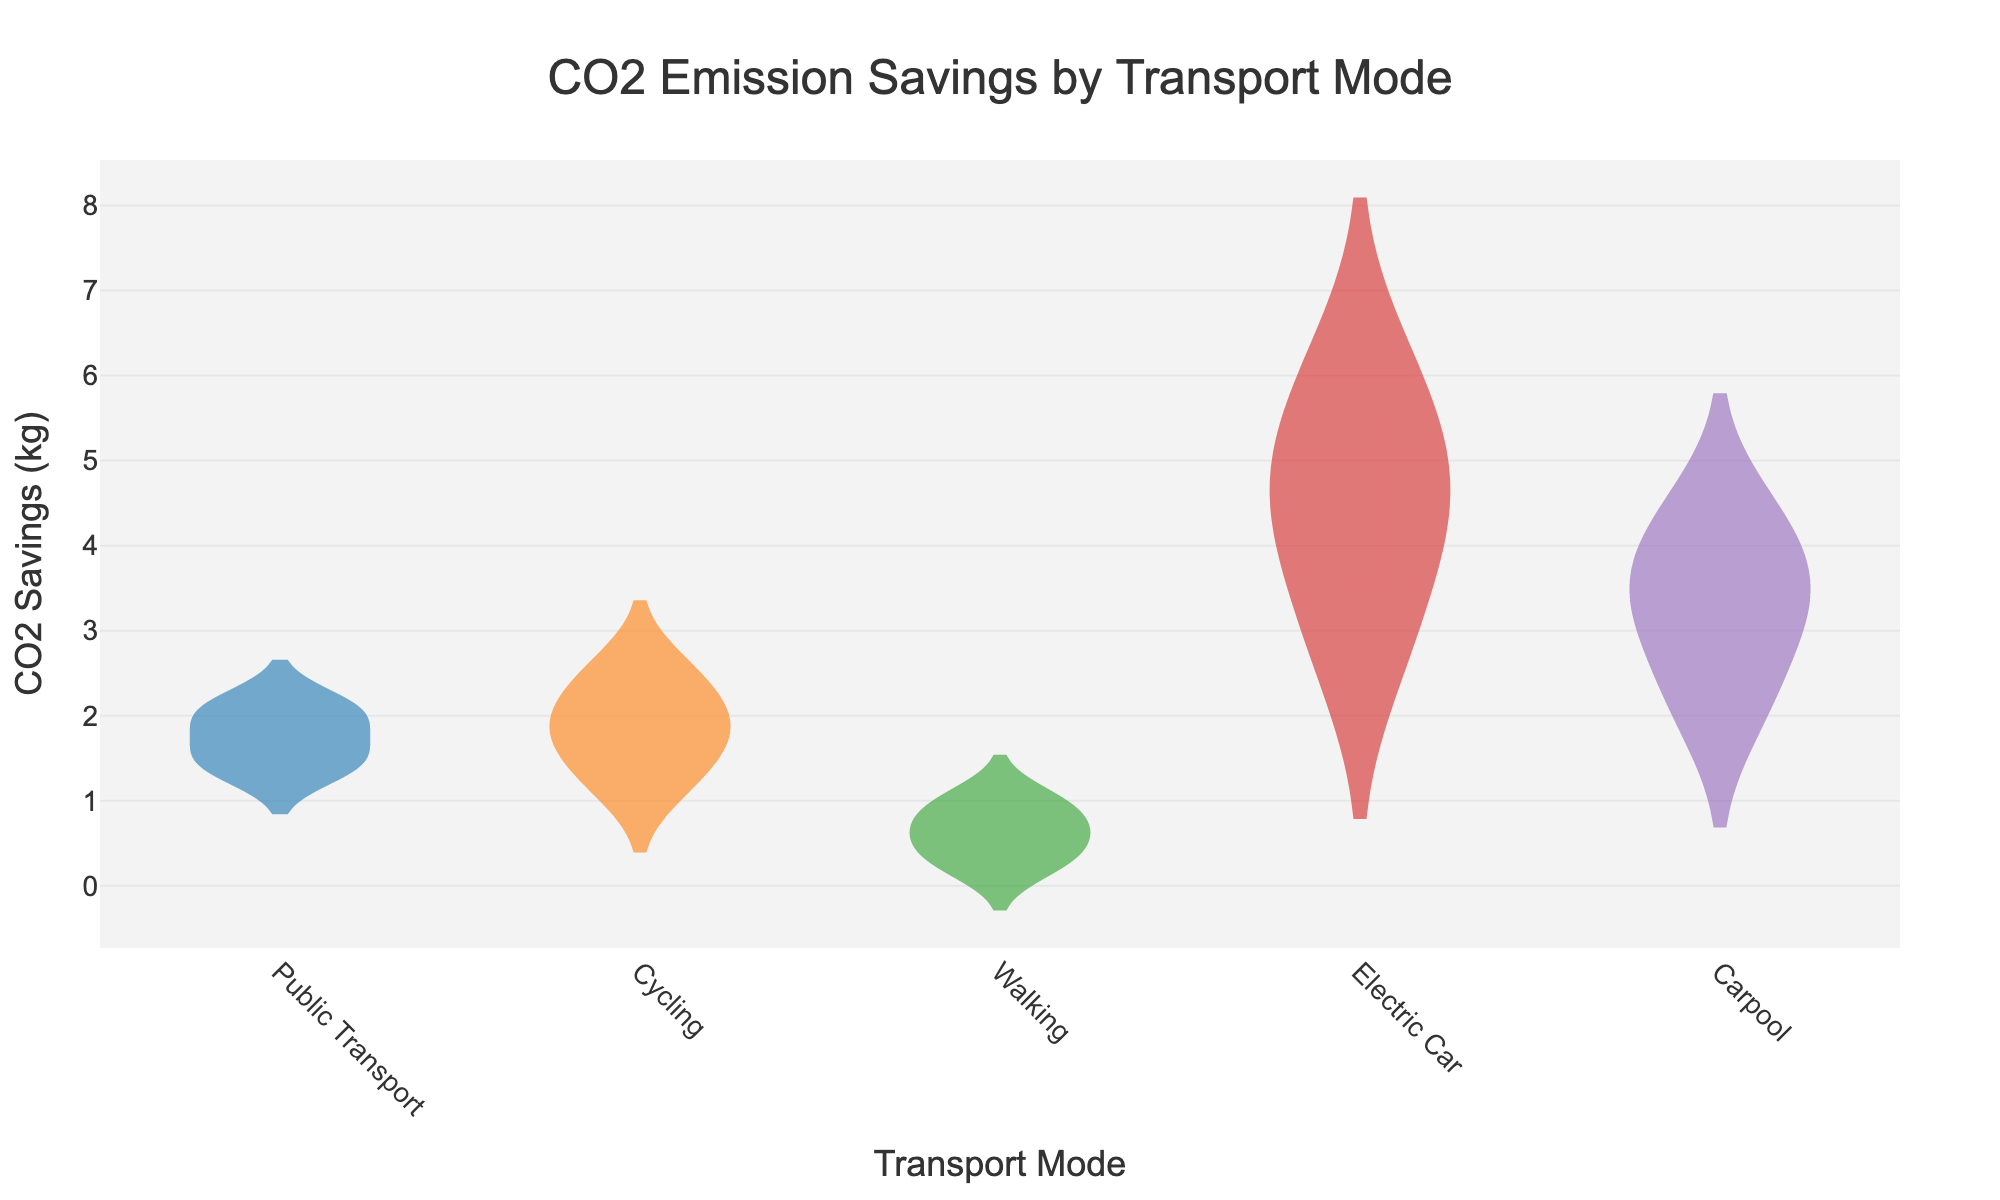Which transport mode has the highest median CO2 savings? To find the median CO2 savings for each transport mode, look at the white line in the center of each box plot overlay inside the violin plots. Compare these lines among the different modes.
Answer: Electric Car Which transport modes show a box plot extending to the highest CO2 savings value? Observe the highest point of the vertical range in the box plot for each transport mode within the violin plot. The mode with the highest extending box plot indicates the highest CO2 savings value.
Answer: Electric Car Is the interquartile range (IQR) of CO2 savings larger for carpool or public transport? To compare the IQR, look at the range between the bottom and top edges of the boxes in the box plots for carpool and public transport. The wider the range, the larger the IQR.
Answer: Public Transport Which transport mode has the least variability in CO2 savings? Evaluate the width and spread of each violin plot. The narrower and more concentrated a violin plot is, the less variability it has.
Answer: Electric Car Which transport mode has the highest mean CO2 savings? The mean CO2 savings can be identified by the dashed line in the center of each box plot. Check which transport mode’s mean line is located highest.
Answer: Electric Car How do the CO2 savings for electric cars compare to those for walking? Compare the overall shape, median, and range of the violin plots for electric cars and walking. Electric cars tend to have much higher savings as indicated by their significantly higher box plot range and median.
Answer: Electric cars have much higher CO2 savings than walking Are cycling and walking CO2 savings distributions overlapping in terms of their entire range of values? Look at the range of values that the violin plots of cycling and walking extend over. If the ranges overlap, the distributions overlap.
Answer: Yes, they overlap Which transport mode shows the greatest upward skew in CO2 savings distribution? Skewness can be seen in the shape of the violin plot. If one tail is much longer than the other, it indicates skewness. Find the transport mode with the longest upper tail in the violin plot.
Answer: Carpool 